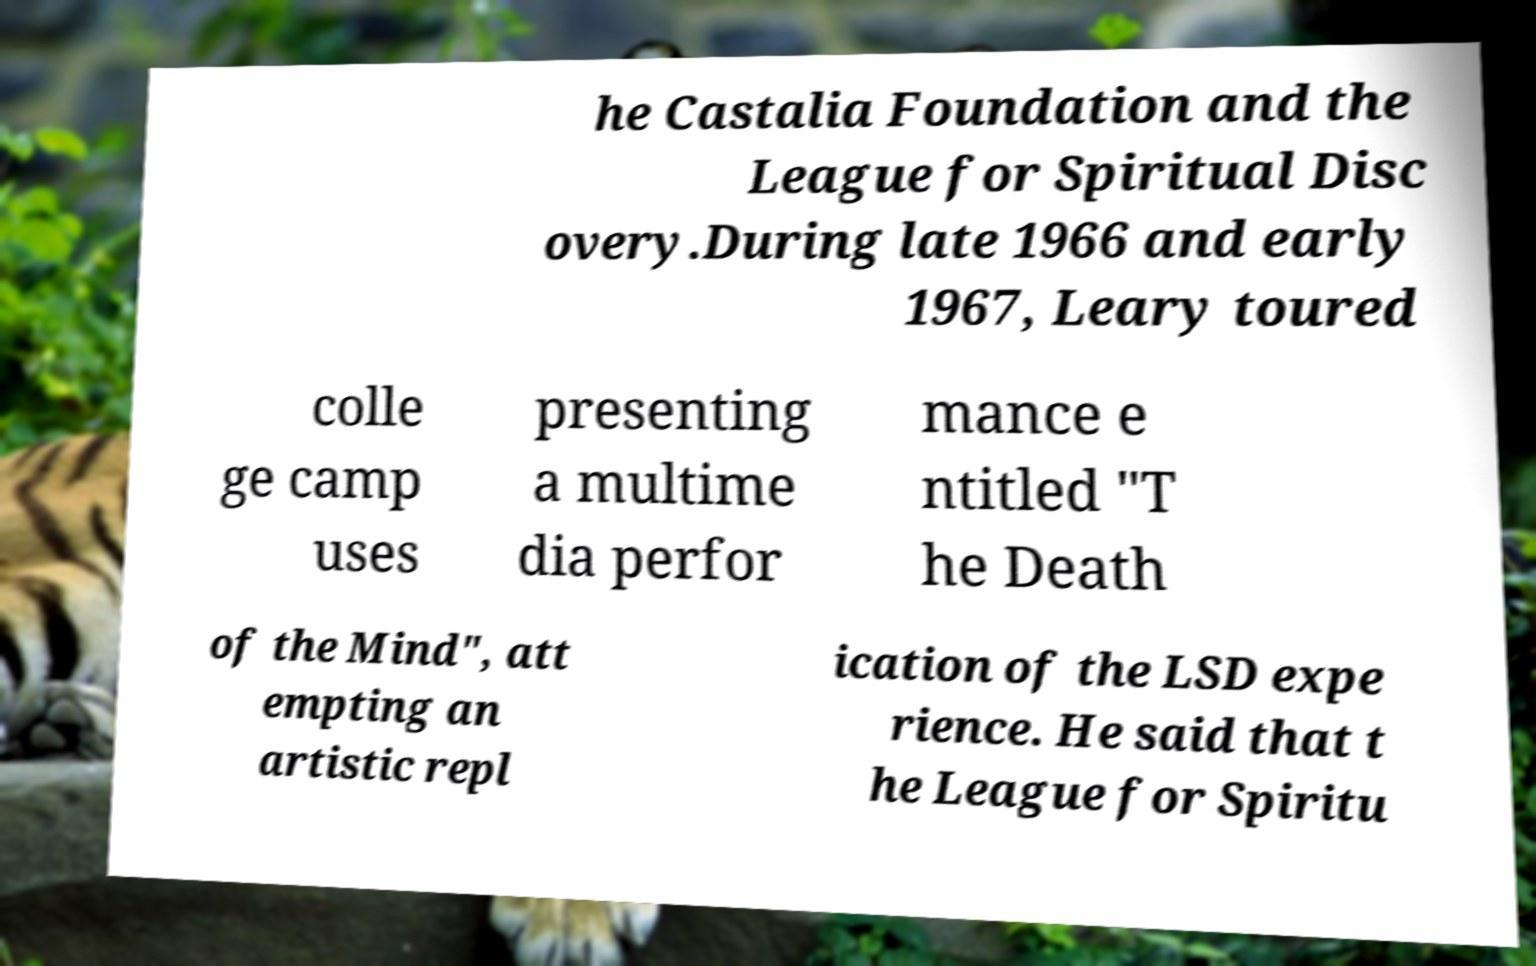Please identify and transcribe the text found in this image. he Castalia Foundation and the League for Spiritual Disc overy.During late 1966 and early 1967, Leary toured colle ge camp uses presenting a multime dia perfor mance e ntitled "T he Death of the Mind", att empting an artistic repl ication of the LSD expe rience. He said that t he League for Spiritu 